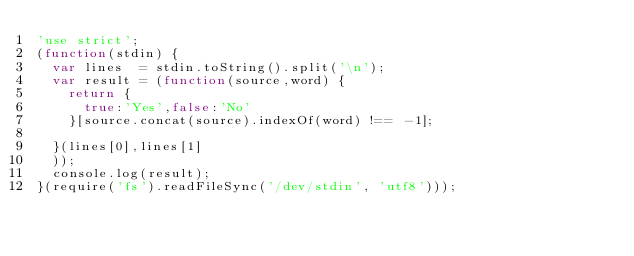Convert code to text. <code><loc_0><loc_0><loc_500><loc_500><_JavaScript_>'use strict';
(function(stdin) {
  var lines  = stdin.toString().split('\n');
  var result = (function(source,word) {
    return {
      true:'Yes',false:'No'
    }[source.concat(source).indexOf(word) !== -1];

  }(lines[0],lines[1]
  ));
  console.log(result);
}(require('fs').readFileSync('/dev/stdin', 'utf8')));</code> 